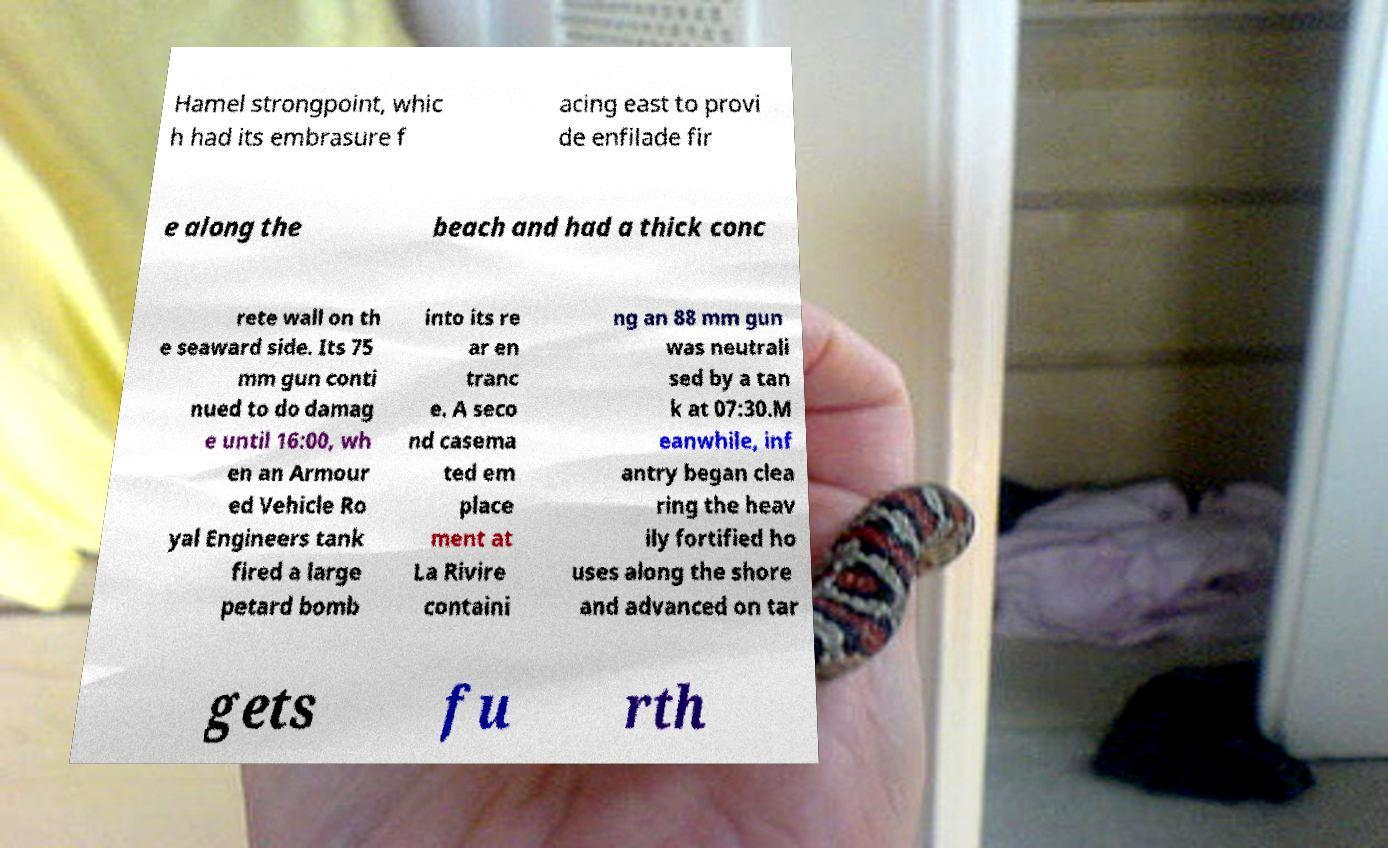For documentation purposes, I need the text within this image transcribed. Could you provide that? Hamel strongpoint, whic h had its embrasure f acing east to provi de enfilade fir e along the beach and had a thick conc rete wall on th e seaward side. Its 75 mm gun conti nued to do damag e until 16:00, wh en an Armour ed Vehicle Ro yal Engineers tank fired a large petard bomb into its re ar en tranc e. A seco nd casema ted em place ment at La Rivire containi ng an 88 mm gun was neutrali sed by a tan k at 07:30.M eanwhile, inf antry began clea ring the heav ily fortified ho uses along the shore and advanced on tar gets fu rth 